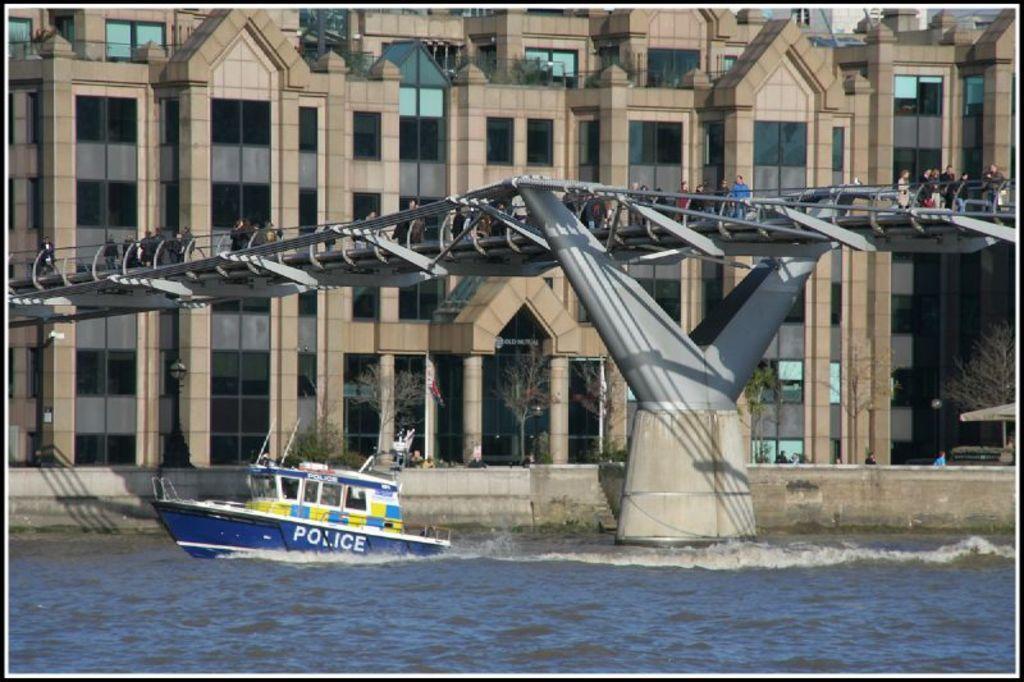How would you summarize this image in a sentence or two? In this image we can see a boat on the water and there is some text on the boat and there is a bridge over the water. We can see some people on the bridge and there is a building in the background and we can see some people in front of the building and there are some trees. 